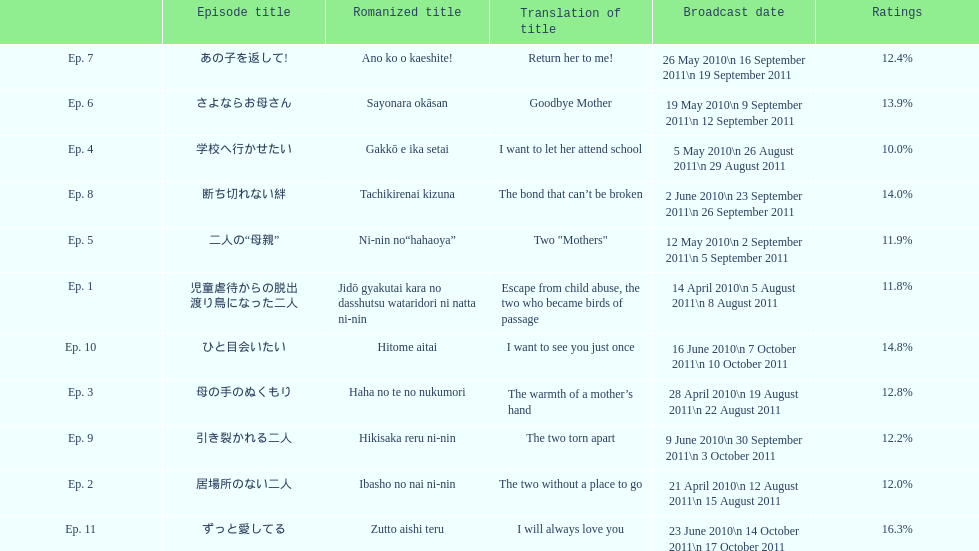How many episodes had a consecutive rating over 11%? 7. 